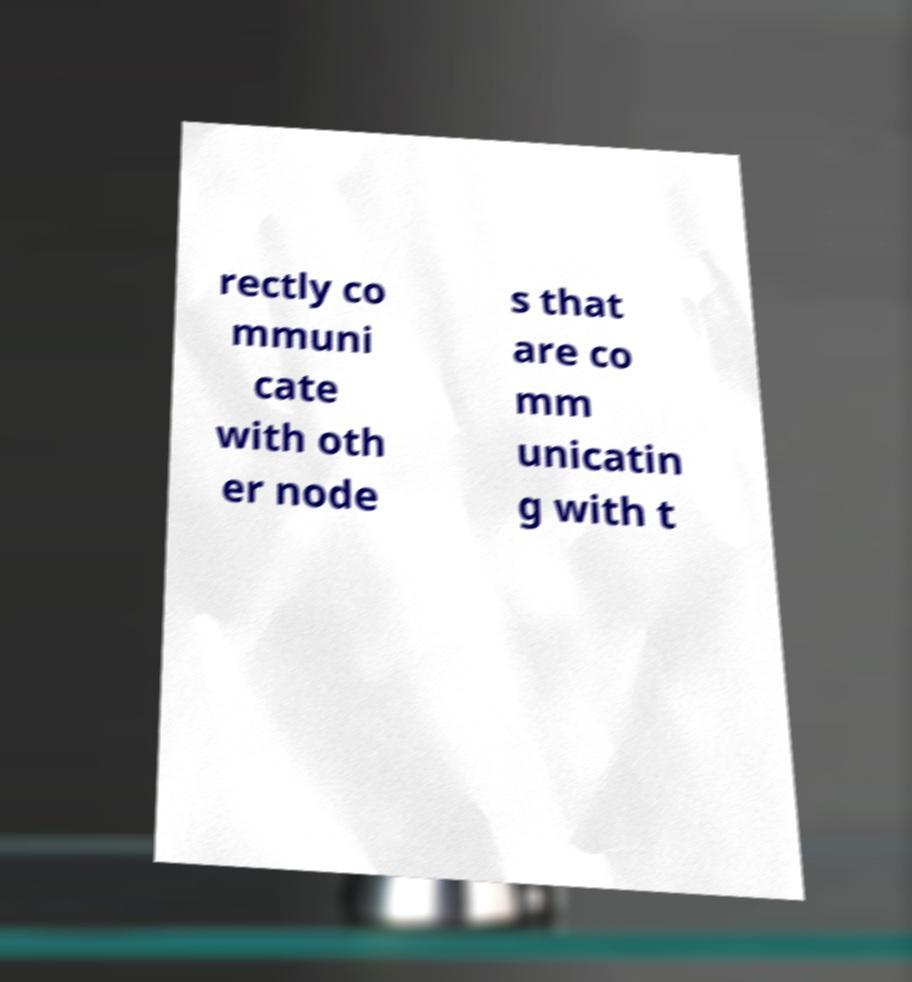Could you assist in decoding the text presented in this image and type it out clearly? rectly co mmuni cate with oth er node s that are co mm unicatin g with t 